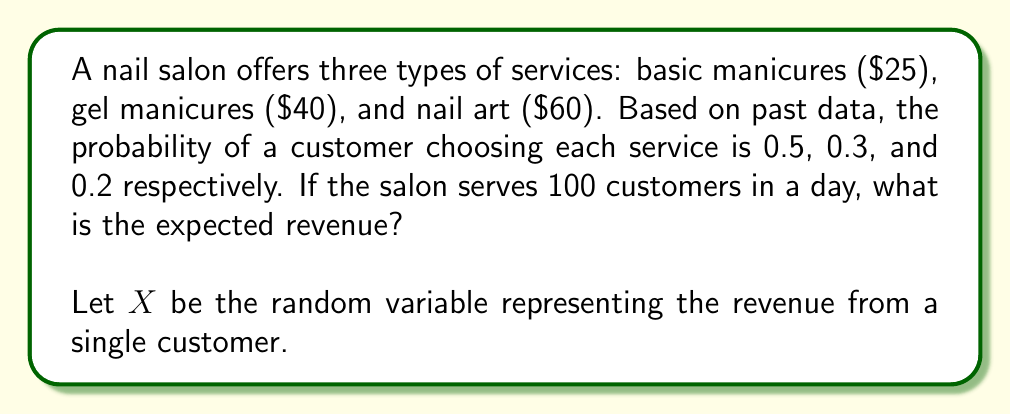What is the answer to this math problem? To solve this problem, we'll follow these steps:

1) First, let's define the probability distribution of $X$:
   
   $P(X = 25) = 0.5$
   $P(X = 40) = 0.3$
   $P(X = 60) = 0.2$

2) Now, we can calculate the expected value of $X$:

   $E(X) = \sum_{x} x \cdot P(X = x)$

   $E(X) = 25 \cdot 0.5 + 40 \cdot 0.3 + 60 \cdot 0.2$

3) Let's compute this:

   $E(X) = 12.5 + 12 + 12 = 36.5$

4) This means that the expected revenue from a single customer is $36.5.

5) Since the salon serves 100 customers in a day, we multiply this by 100:

   Expected daily revenue $= 100 \cdot E(X) = 100 \cdot 36.5 = 3650$

Therefore, the expected revenue from 100 customers is $3650.
Answer: $3650 